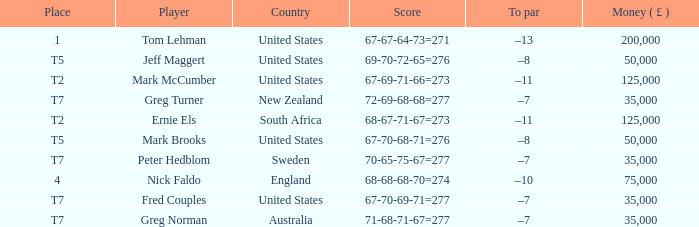Could you help me parse every detail presented in this table? {'header': ['Place', 'Player', 'Country', 'Score', 'To par', 'Money ( £ )'], 'rows': [['1', 'Tom Lehman', 'United States', '67-67-64-73=271', '–13', '200,000'], ['T5', 'Jeff Maggert', 'United States', '69-70-72-65=276', '–8', '50,000'], ['T2', 'Mark McCumber', 'United States', '67-69-71-66=273', '–11', '125,000'], ['T7', 'Greg Turner', 'New Zealand', '72-69-68-68=277', '–7', '35,000'], ['T2', 'Ernie Els', 'South Africa', '68-67-71-67=273', '–11', '125,000'], ['T5', 'Mark Brooks', 'United States', '67-70-68-71=276', '–8', '50,000'], ['T7', 'Peter Hedblom', 'Sweden', '70-65-75-67=277', '–7', '35,000'], ['4', 'Nick Faldo', 'England', '68-68-68-70=274', '–10', '75,000'], ['T7', 'Fred Couples', 'United States', '67-70-69-71=277', '–7', '35,000'], ['T7', 'Greg Norman', 'Australia', '71-68-71-67=277', '–7', '35,000']]} What is To par, when Player is "Greg Turner"? –7. 